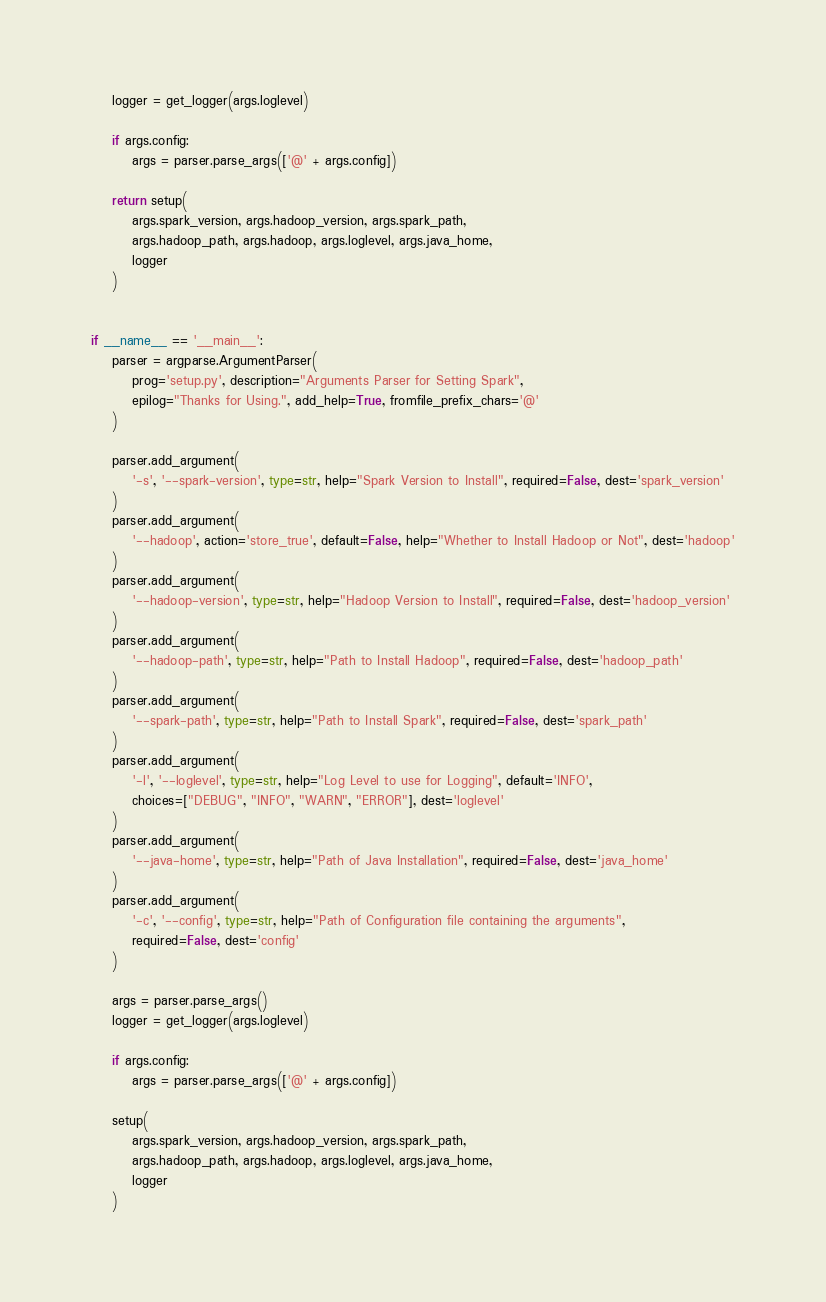Convert code to text. <code><loc_0><loc_0><loc_500><loc_500><_Python_>    logger = get_logger(args.loglevel)

    if args.config:
        args = parser.parse_args(['@' + args.config])

    return setup(
        args.spark_version, args.hadoop_version, args.spark_path,
        args.hadoop_path, args.hadoop, args.loglevel, args.java_home,
        logger
    )


if __name__ == '__main__':
    parser = argparse.ArgumentParser(
        prog='setup.py', description="Arguments Parser for Setting Spark",
        epilog="Thanks for Using.", add_help=True, fromfile_prefix_chars='@'
    )

    parser.add_argument(
        '-s', '--spark-version', type=str, help="Spark Version to Install", required=False, dest='spark_version'
    )
    parser.add_argument(
        '--hadoop', action='store_true', default=False, help="Whether to Install Hadoop or Not", dest='hadoop'
    )
    parser.add_argument(
        '--hadoop-version', type=str, help="Hadoop Version to Install", required=False, dest='hadoop_version'
    )
    parser.add_argument(
        '--hadoop-path', type=str, help="Path to Install Hadoop", required=False, dest='hadoop_path'
    )
    parser.add_argument(
        '--spark-path', type=str, help="Path to Install Spark", required=False, dest='spark_path'
    )
    parser.add_argument(
        '-l', '--loglevel', type=str, help="Log Level to use for Logging", default='INFO',
        choices=["DEBUG", "INFO", "WARN", "ERROR"], dest='loglevel'
    )
    parser.add_argument(
        '--java-home', type=str, help="Path of Java Installation", required=False, dest='java_home'
    )
    parser.add_argument(
        '-c', '--config', type=str, help="Path of Configuration file containing the arguments",
        required=False, dest='config'
    )

    args = parser.parse_args()
    logger = get_logger(args.loglevel)

    if args.config:
        args = parser.parse_args(['@' + args.config])

    setup(
        args.spark_version, args.hadoop_version, args.spark_path,
        args.hadoop_path, args.hadoop, args.loglevel, args.java_home,
        logger
    )
</code> 